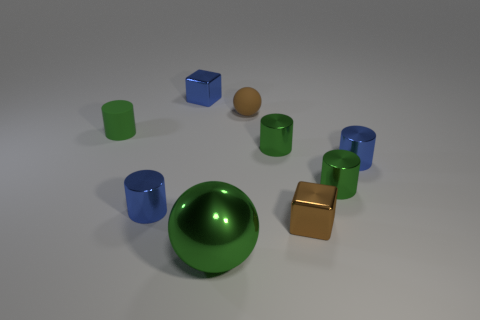How many brown rubber objects have the same size as the rubber cylinder?
Your answer should be compact. 1. The small rubber ball has what color?
Your response must be concise. Brown. Is the color of the large metal sphere the same as the shiny cylinder to the left of the brown rubber sphere?
Provide a short and direct response. No. There is a green cylinder that is the same material as the brown ball; what is its size?
Keep it short and to the point. Small. Are there any other tiny rubber spheres of the same color as the matte sphere?
Make the answer very short. No. How many things are tiny metallic cubes that are to the left of the matte ball or small green cylinders?
Ensure brevity in your answer.  4. Is the material of the brown cube the same as the large green sphere that is in front of the brown rubber sphere?
Provide a short and direct response. Yes. There is a ball that is the same color as the rubber cylinder; what is its size?
Make the answer very short. Large. Are there any big blue cylinders that have the same material as the brown block?
Offer a terse response. No. How many things are small matte things that are in front of the tiny brown matte thing or small green cylinders that are to the left of the big green metallic object?
Your answer should be compact. 1. 